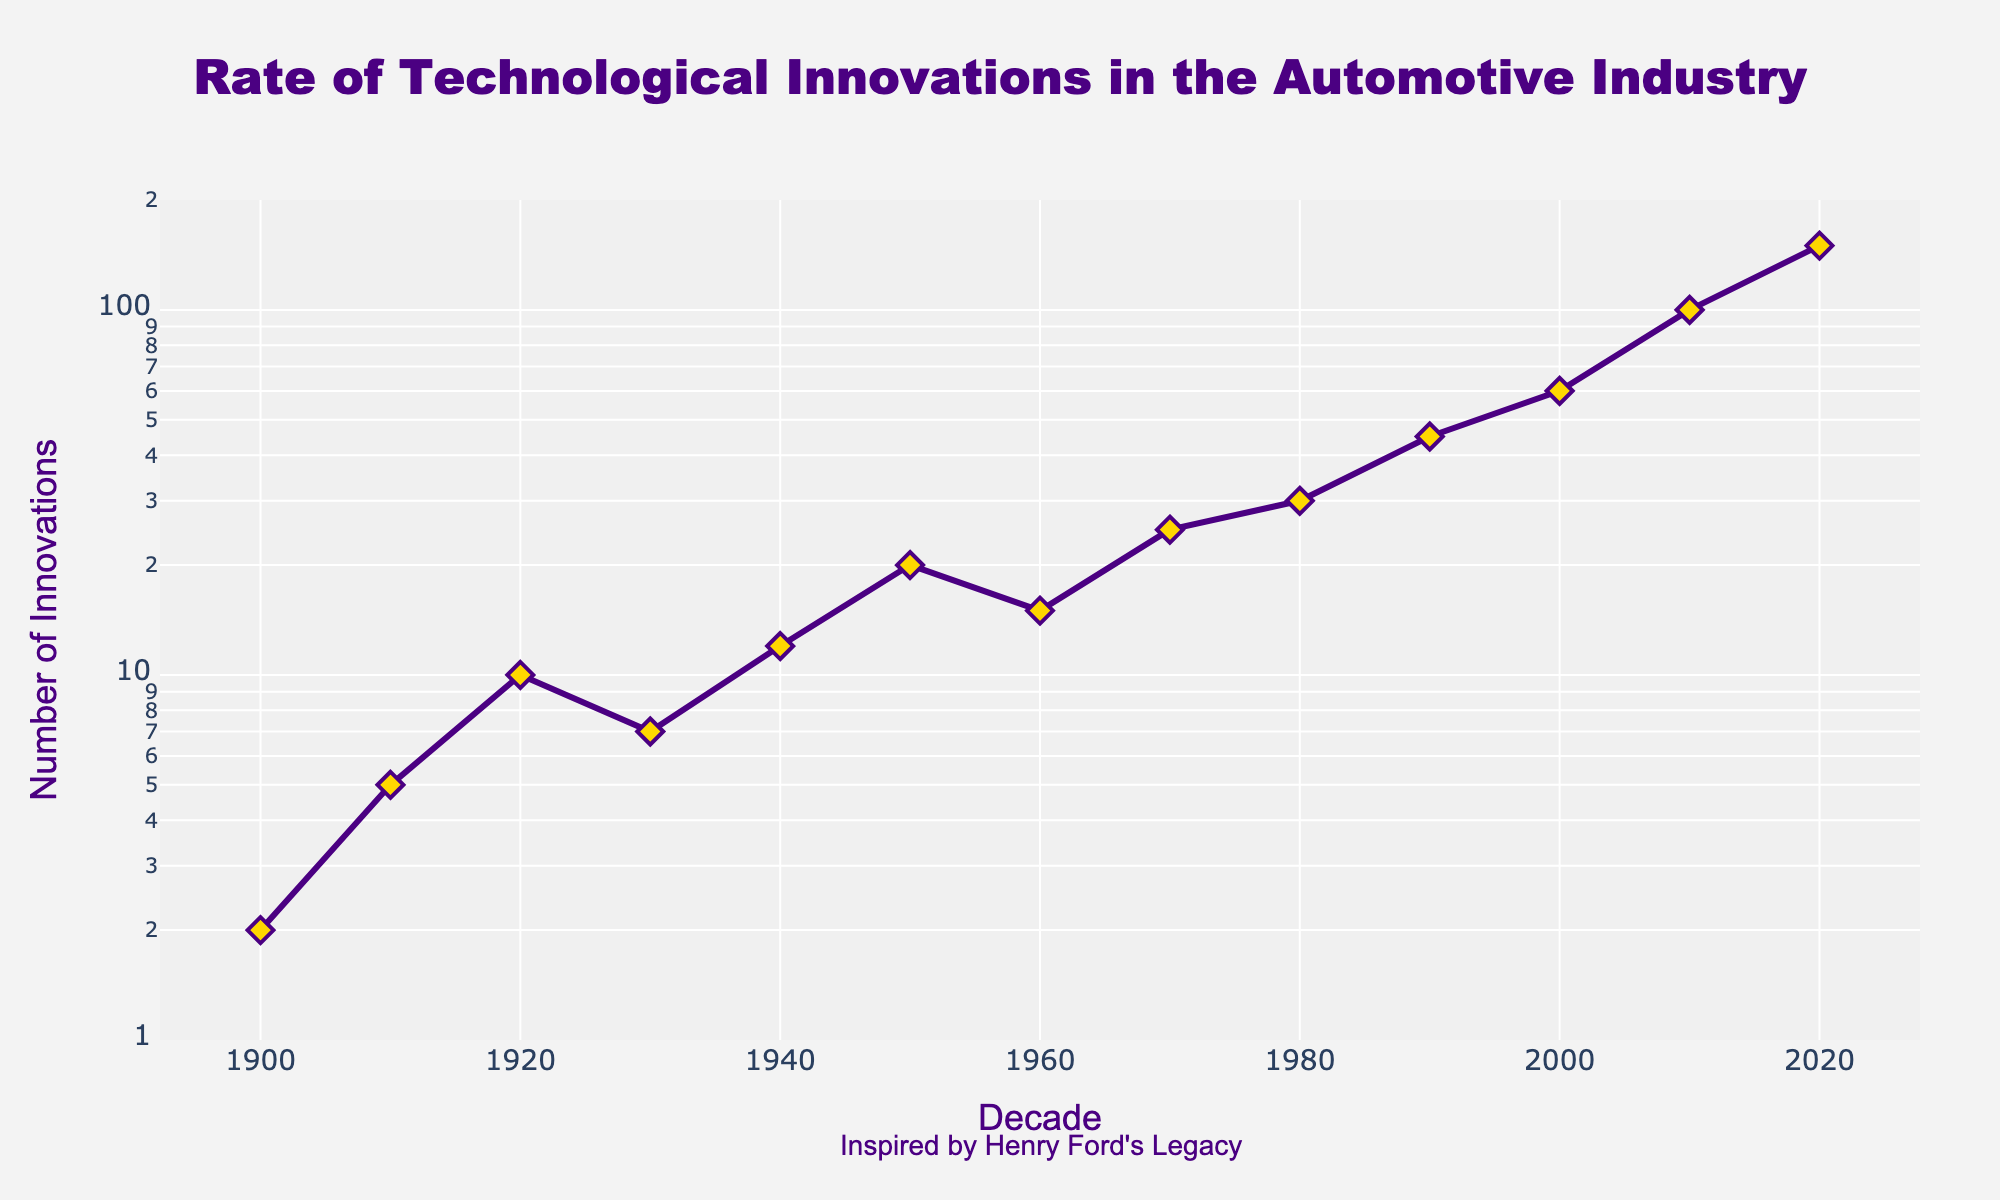What is the title of the plot? The title of the plot is mentioned at the top of the figure.
Answer: Rate of Technological Innovations in the Automotive Industry What does the y-axis represent? The y-axis represents the number of innovations, labeled as 'Number of Innovations'.
Answer: Number of Innovations How many decades are depicted in the plot? The data spans from the 1900s to the 2020s, inclusive, which covers 13 decades.
Answer: 13 Which decade shows the highest number of innovations? The last data point on the far right of the x-axis at 2020s has the highest value on the y-axis.
Answer: 2020s What is the approximate number of innovations in the 2010s? The data point for the 2010s is positioned at around 100 on the y-axis.
Answer: 100 How are the data points marked on the plot? The data points are marked with yellow diamonds with a blue outline.
Answer: Yellow diamonds with blue outline Which decade saw the first substantial increase in innovations compared to the previous decade? The number of innovations in the 1950s is significantly higher than the 1940s, approximately from 12 to 20.
Answer: 1950s What can you infer about the trend of technological innovations over the decades? The trend shows that the number of innovations generally increased over time, with a rapid increase in the recent decades.
Answer: Generally increasing, rapid increase in recent decades Explain how the innovations changed between the 1960s and 1980s. From the 1960s to the 1970s, innovations increased by 10 units, and from the 1970s to the 1980s, innovations increased by 5 units.
Answer: Increased by 10 units from 1960s to 1970s, and by 5 units from 1970s to 1980s By approximately how many innovations did the rate increase from the 1900s to the 2000s? Innovations increased from 2 in the 1900s to 60 in the 2000s. The approximate increase is 60 - 2 = 58.
Answer: 58 